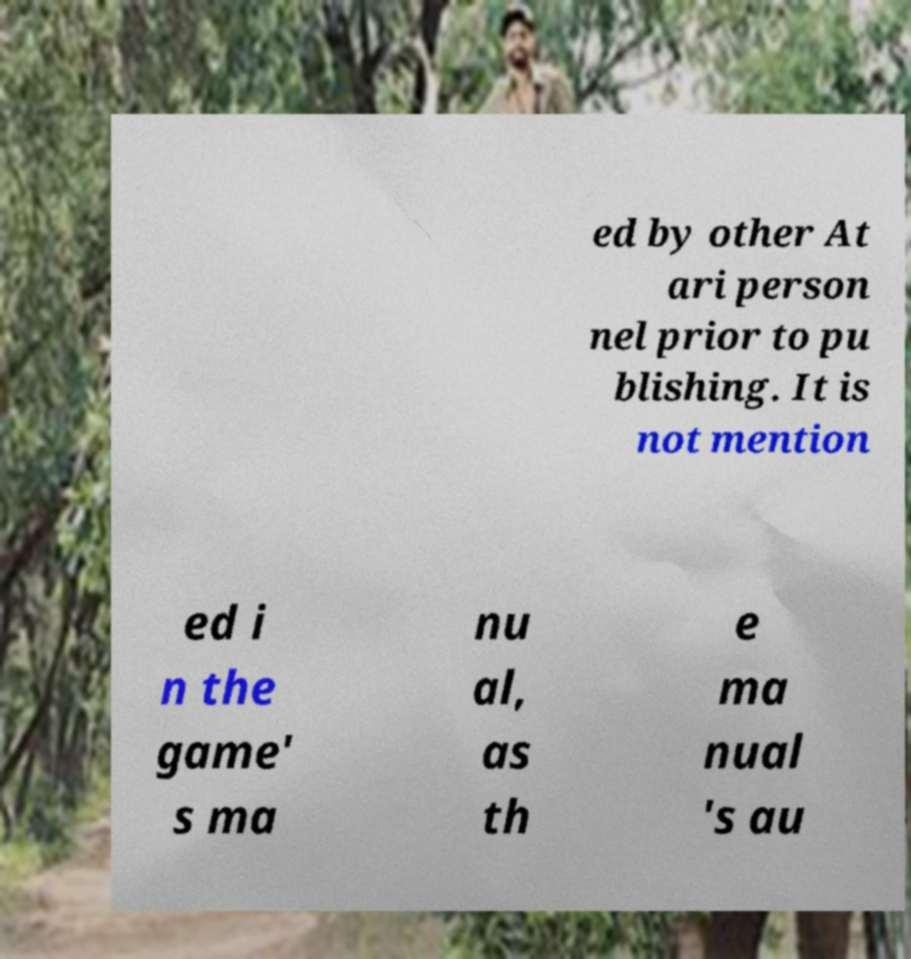There's text embedded in this image that I need extracted. Can you transcribe it verbatim? ed by other At ari person nel prior to pu blishing. It is not mention ed i n the game' s ma nu al, as th e ma nual 's au 